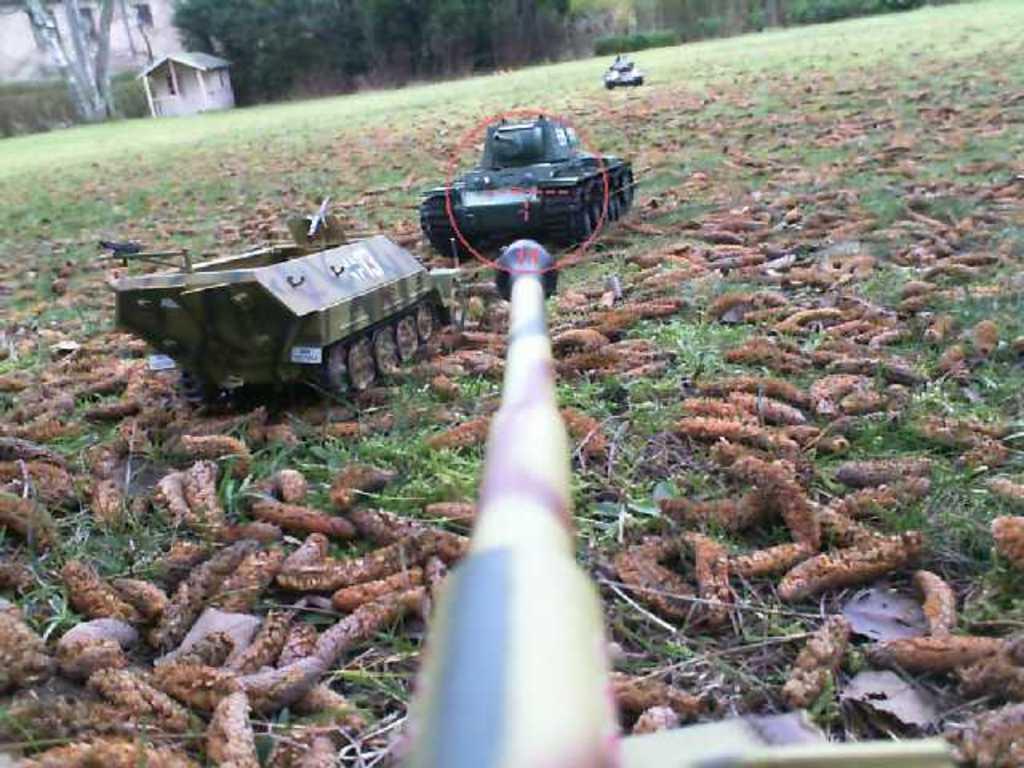Describe this image in one or two sentences. In this picture we can see toys and something on the grass. At the top of the image, there are trees and a house. 